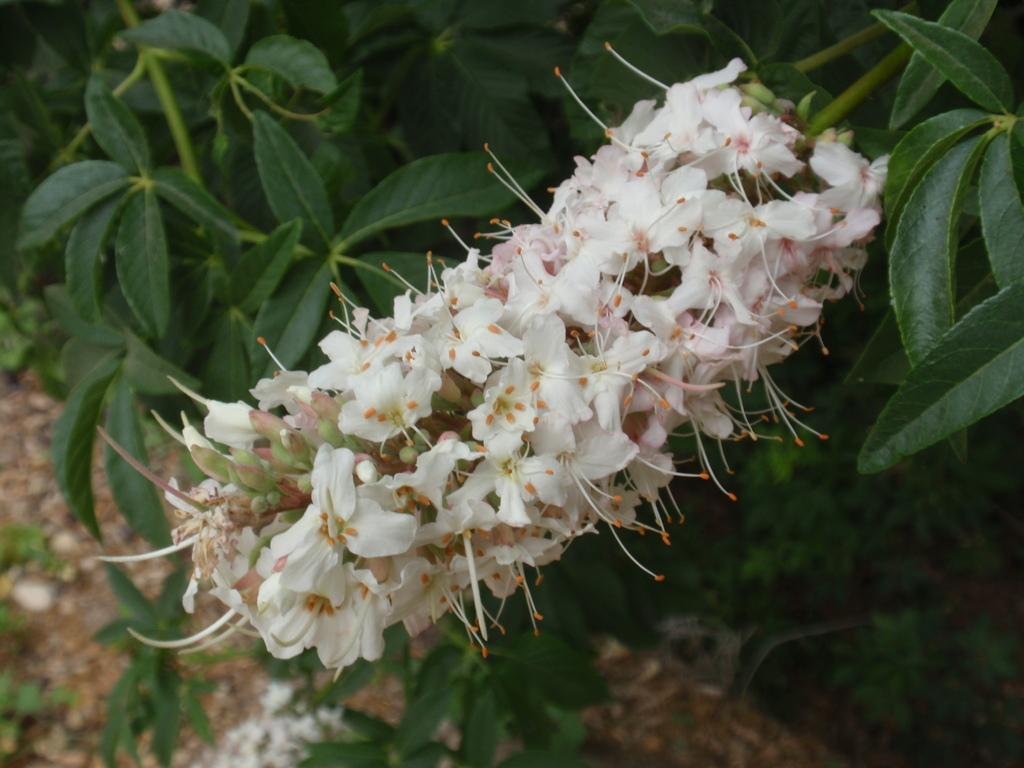What type of living organisms can be seen in the image? Plants can be seen in the image. What specific type of plant is present in the image? There is a group of flowers in the image. What is the color of the flowers in the image? The flowers are white in color. What sound do the flowers make when they are touched in the image? There is no sound made by the flowers in the image, as flowers do not produce sound. 